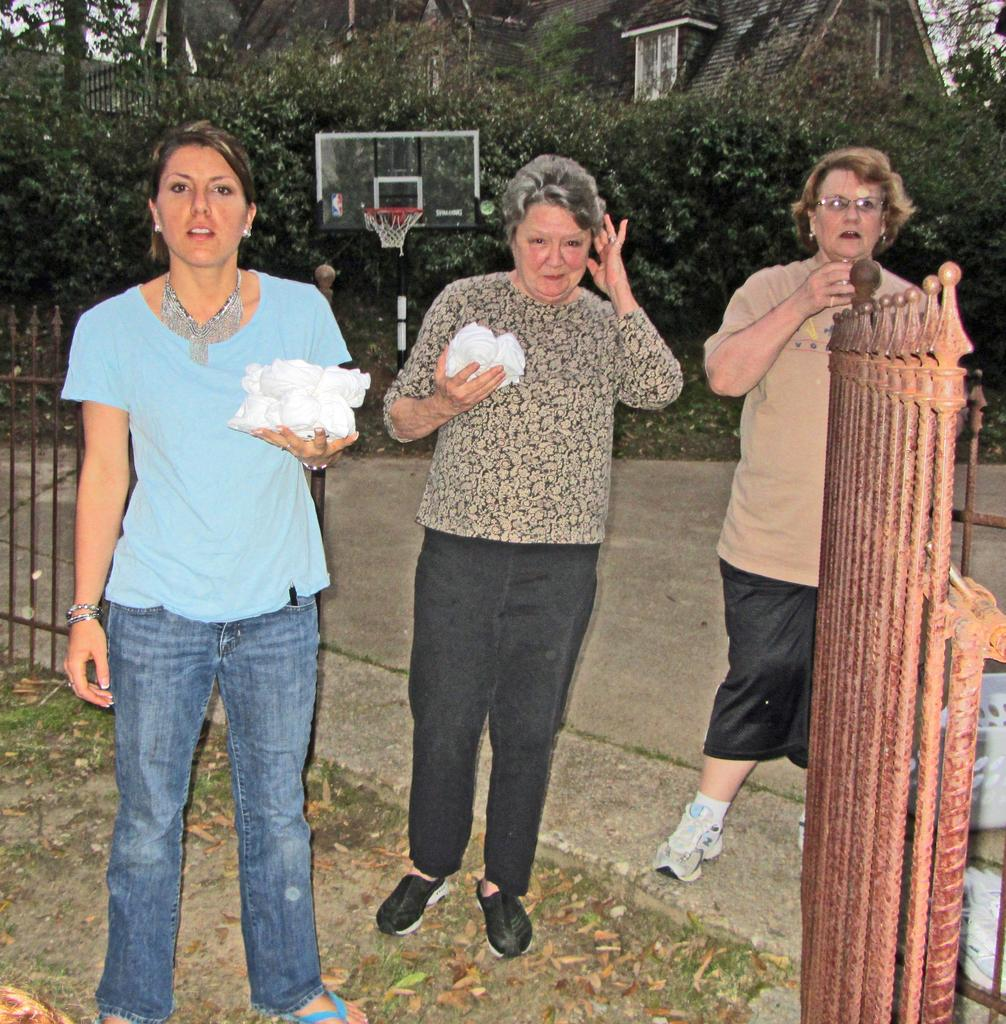How many people are in the image? There are three persons in the image. What are two of the persons doing in the image? Two of the persons are holding objects. What can be seen in the background of the image? There is a basketball net, trees, houses, and a fence in the image. What is on the ground in the image? There are leaves on the ground in the image. What type of stamp can be seen on the basketball net in the image? There is no stamp present on the basketball net in the image. 